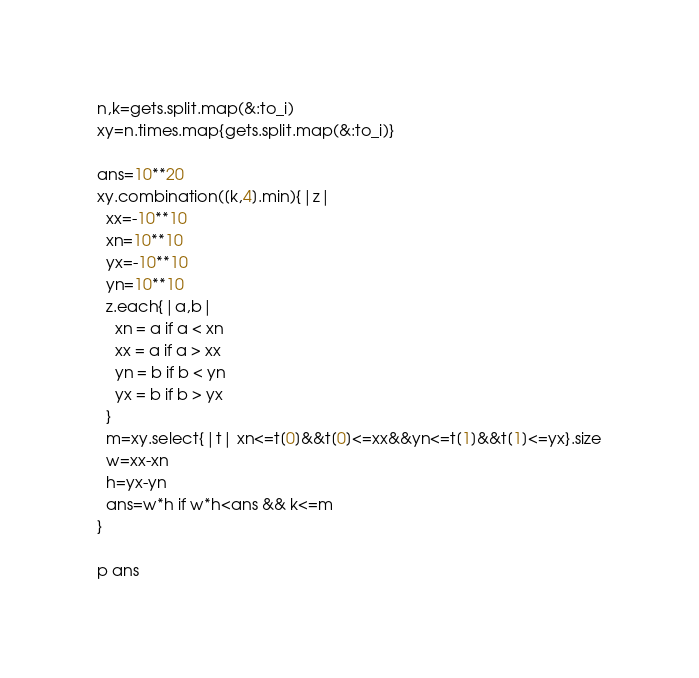Convert code to text. <code><loc_0><loc_0><loc_500><loc_500><_Ruby_>n,k=gets.split.map(&:to_i)
xy=n.times.map{gets.split.map(&:to_i)}

ans=10**20
xy.combination([k,4].min){|z|
  xx=-10**10
  xn=10**10
  yx=-10**10
  yn=10**10
  z.each{|a,b|
    xn = a if a < xn
    xx = a if a > xx
    yn = b if b < yn
    yx = b if b > yx
  }
  m=xy.select{|t| xn<=t[0]&&t[0]<=xx&&yn<=t[1]&&t[1]<=yx}.size
  w=xx-xn
  h=yx-yn
  ans=w*h if w*h<ans && k<=m
}

p ans</code> 